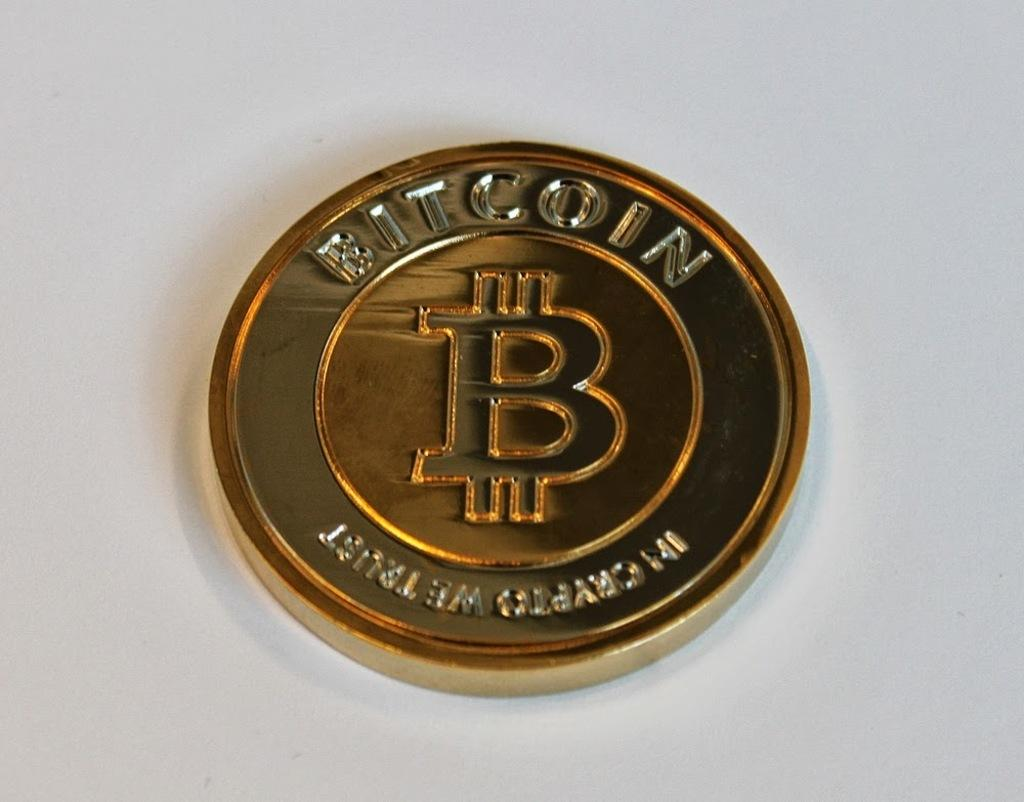<image>
Offer a succinct explanation of the picture presented. Gold Bitcoin coin that has a letter B in the middle. 